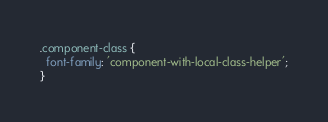Convert code to text. <code><loc_0><loc_0><loc_500><loc_500><_CSS_>.component-class {
  font-family: 'component-with-local-class-helper';
}
</code> 